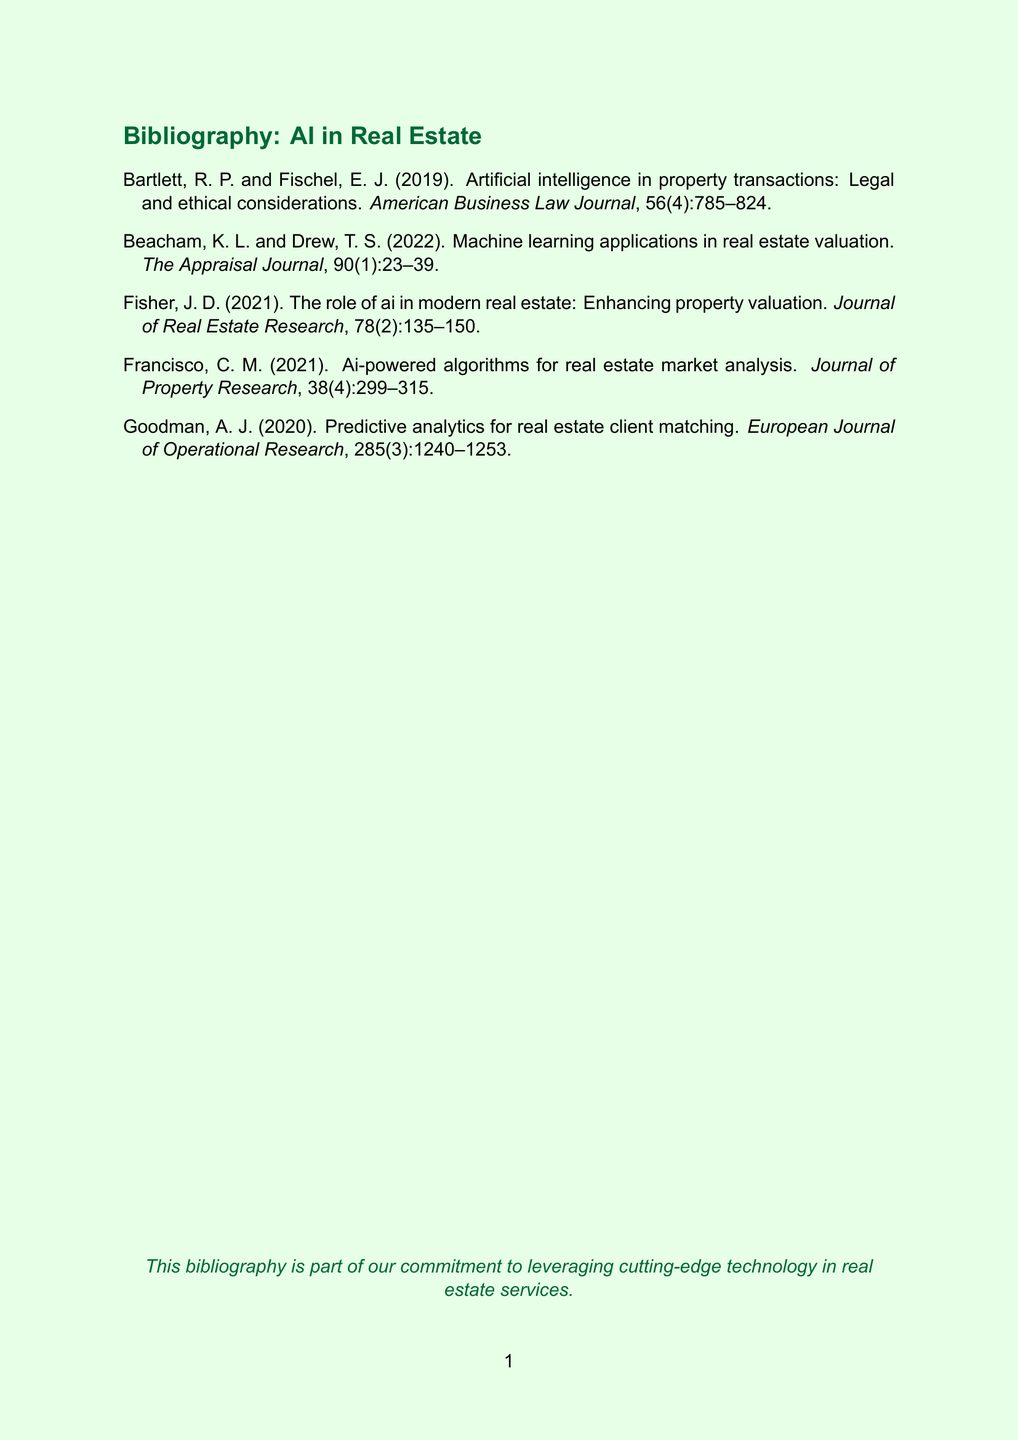what is the title of the first paper in the bibliography? The title of the first paper is listed right after the authors in the bibliography section.
Answer: Artificial intelligence in property transactions: Legal and ethical considerations who are the authors of the second paper? The authors of the second paper are presented at the beginning of the citation.
Answer: K.L. Beacham and T.S. Drew what year was the paper on AI-powered algorithms published? The publication year is indicated in parentheses following the authors' names.
Answer: 2021 which journal features the paper on predictive analytics for real estate client matching? The titles of the journals are prominently listed in each citation.
Answer: European Journal of Operational Research how many papers are authored by a single author? This can be determined by counting the citations with only one author name listed.
Answer: 1 which paper discusses legal and ethical considerations? The topic of legal and ethical considerations is mentioned in the title of the first paper.
Answer: Artificial intelligence in property transactions: Legal and ethical considerations what is the focus of the paper by Francisco in 2021? The focus is described in the title of the paper, indicating its subject matter.
Answer: Ai-powered algorithms for real estate market analysis what is the volume number of the paper published in the Journal of Real Estate Research? The volume number is provided within the citation details after the journal title.
Answer: 78 which authors discuss machine learning applications in real estate valuation? The authors' names are listed at the beginning of the relevant paper citation.
Answer: K.L. Beacham and T.S. Drew 